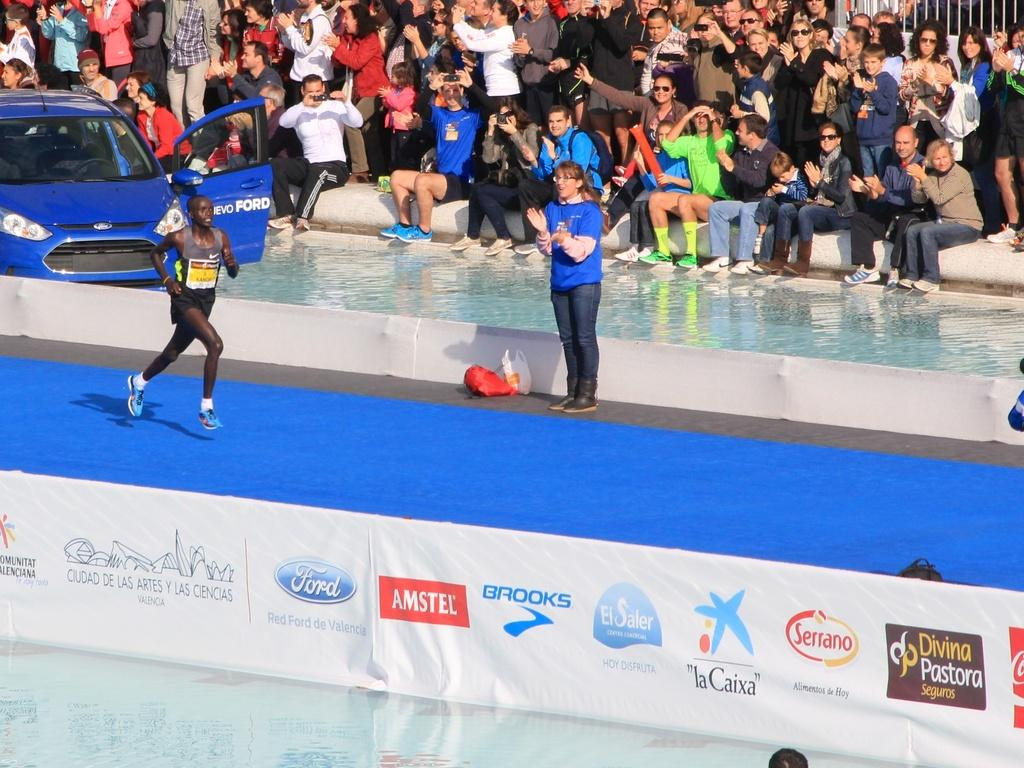What is the main subject of the image? There is a woman standing in the image. What is covering the woman in the image? There is a plastic cover in the image. What can be seen hanging in the image? There are banners in the image. What vehicle is present in the image? There is a car in the image. What is the person in the foreground of the image doing? A person is running on the floor in the image. What can be seen in the background of the image? There is a group of people and some objects visible in the background of the image. What type of legal advice is the woman providing in the image? There is no indication in the image that the woman is providing legal advice or that she is a lawyer. 